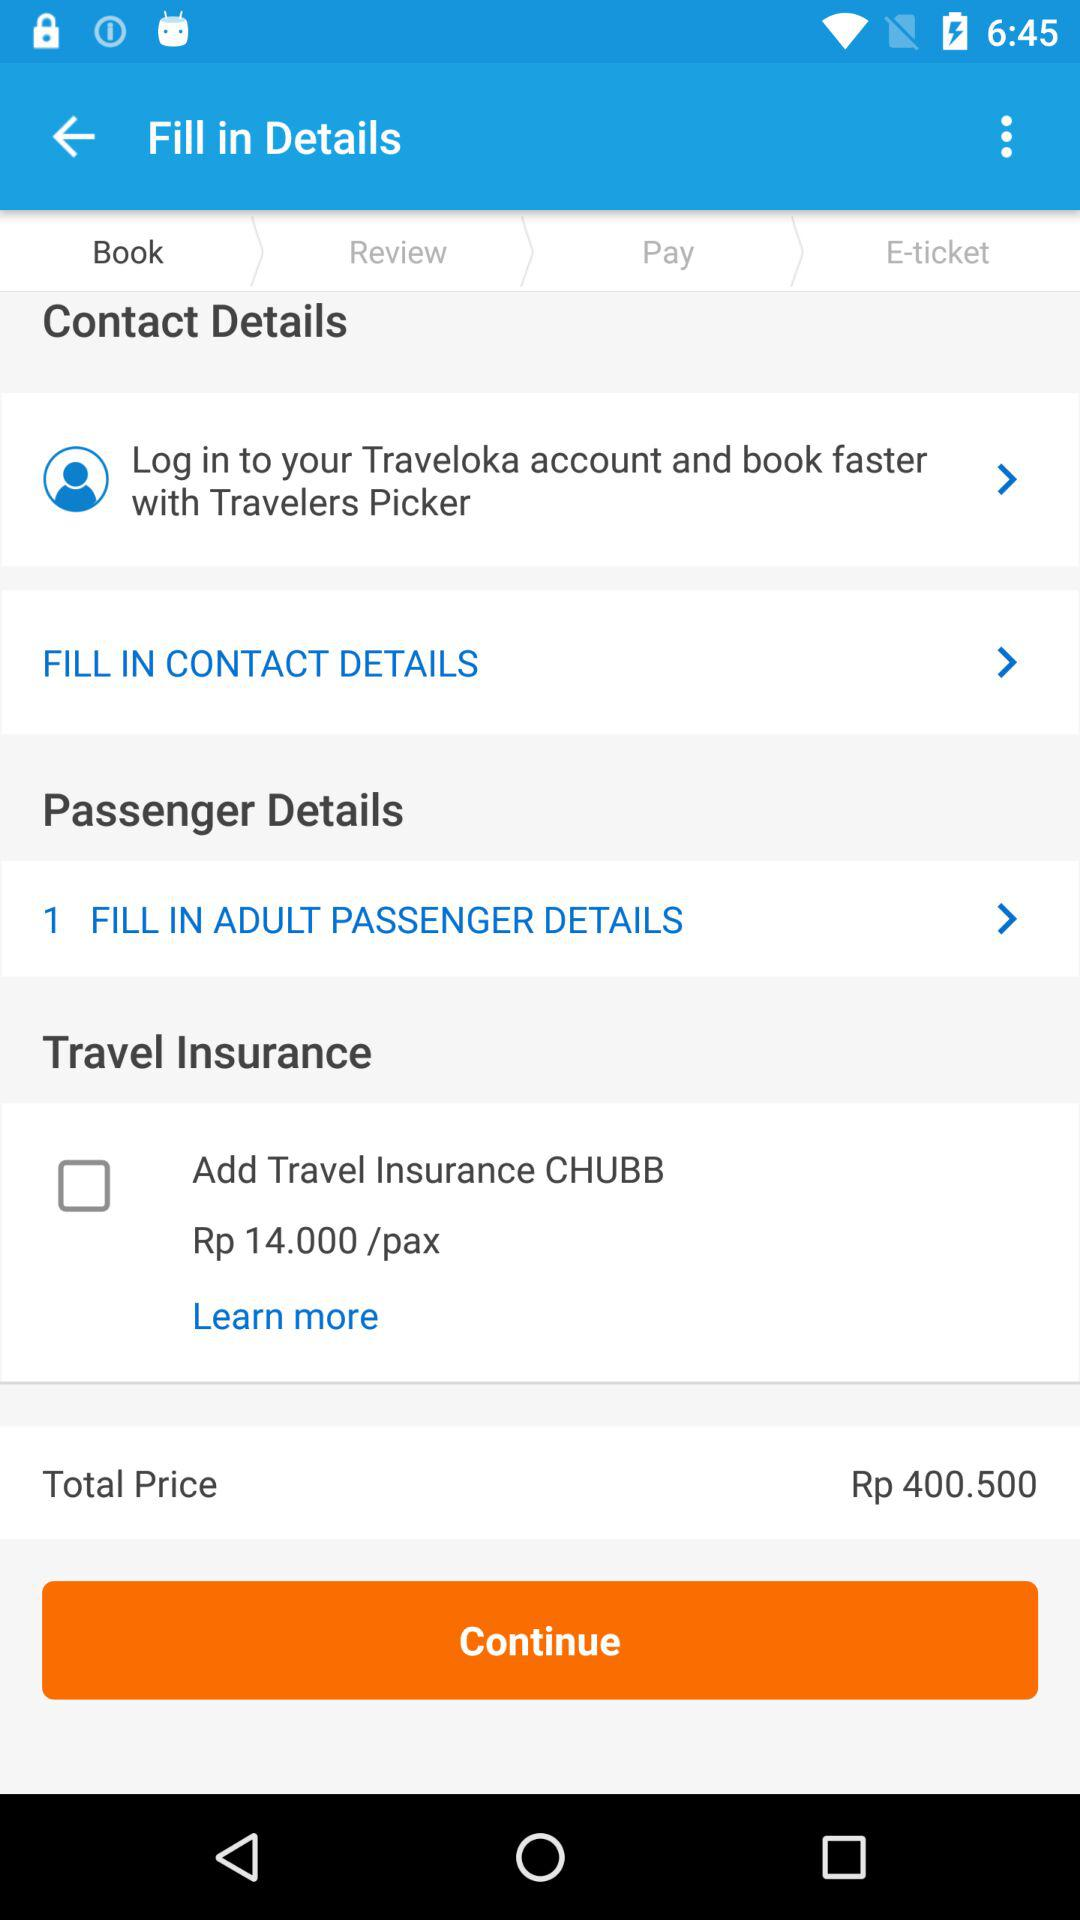Is travel insurance included in the total ticket price shown? No, the travel insurance offered by CHUBB for Rp 14,000 per person is optional and would be an additional cost to the total ticket price if selected. How can I add the travel insurance to my booking? To add the travel insurance, simply check the box next to 'Add Travel Insurance CHUBB' before continuing to payment to ensure it's included in your booking. 